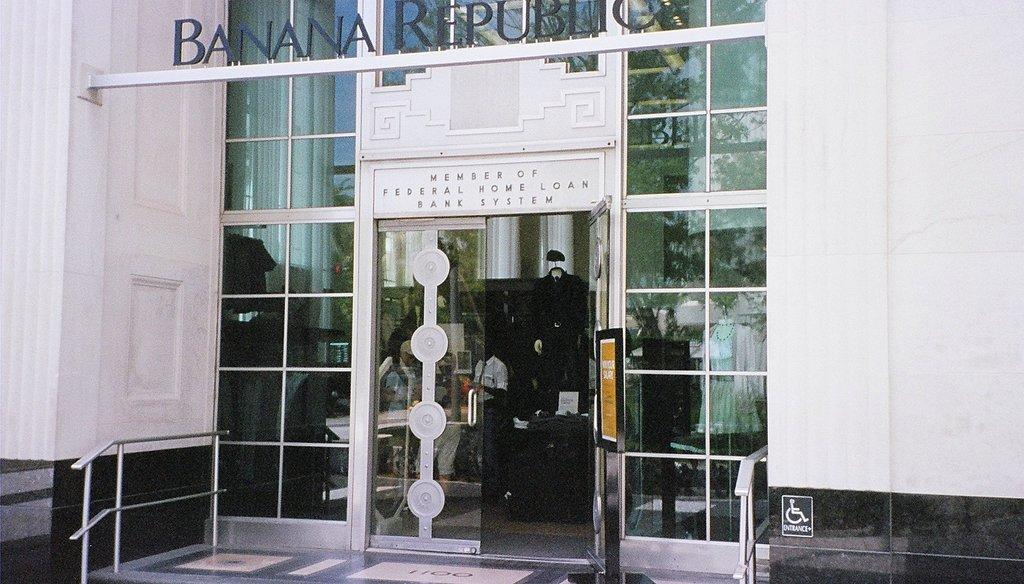What type of structure is visible in the image? There is a building in the image. What part of the building can be seen in the image? There is a door in the image. What material is the door made of? The door is made of glass. Who is present in the image? There is a person standing in the image. What is the person wearing? The person is wearing clothes. What can be seen written or printed in the image? There is a text in the image. What type of barrier is visible in the image? There is a fence in the image. Can you tell me how many goats are running in the image? There are no goats or running depicted in the image; it features a building, a door, a person, text, and a fence. 